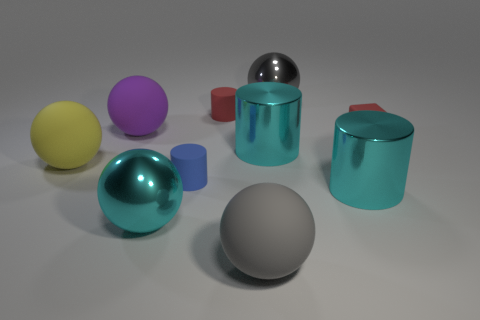Subtract all yellow cylinders. Subtract all gray balls. How many cylinders are left? 4 Subtract all red blocks. How many brown cylinders are left? 0 Add 7 large purples. How many tiny blues exist? 0 Subtract all large purple objects. Subtract all tiny red rubber cylinders. How many objects are left? 8 Add 3 yellow rubber spheres. How many yellow rubber spheres are left? 4 Add 5 green objects. How many green objects exist? 5 Subtract all cyan cylinders. How many cylinders are left? 2 Subtract all cyan metal spheres. How many spheres are left? 4 Subtract 0 blue cubes. How many objects are left? 10 Subtract all cylinders. How many objects are left? 6 